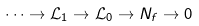<formula> <loc_0><loc_0><loc_500><loc_500>\cdots \to \mathcal { L } _ { 1 } \to \mathcal { L } _ { 0 } \to N _ { f } \to 0</formula> 